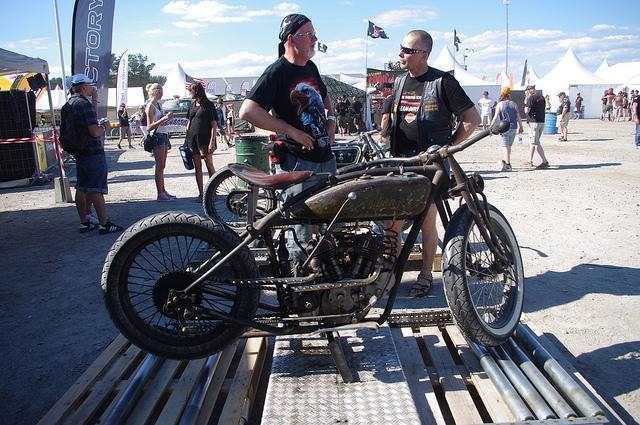How many people are visible?
Give a very brief answer. 5. How many motorcycles are there?
Give a very brief answer. 2. 